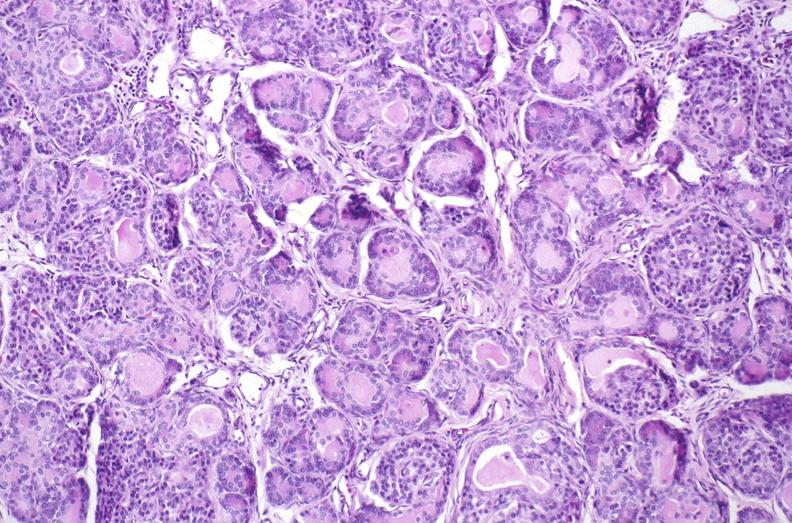where is this?
Answer the question using a single word or phrase. Pancreas 